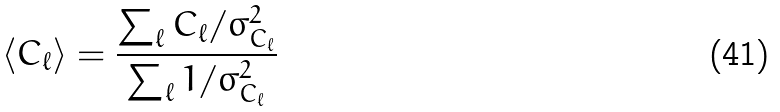Convert formula to latex. <formula><loc_0><loc_0><loc_500><loc_500>\langle C _ { \ell } \rangle = \frac { \sum _ { \ell } C _ { \ell } / \sigma _ { C _ { \ell } } ^ { 2 } } { \sum _ { \ell } 1 / \sigma _ { C _ { \ell } } ^ { 2 } }</formula> 